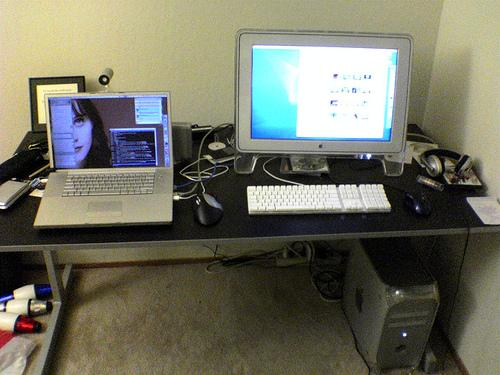How many computer displays are on top of the black desk with two mouses?

Choices:
A) five
B) two
C) four
D) three two 